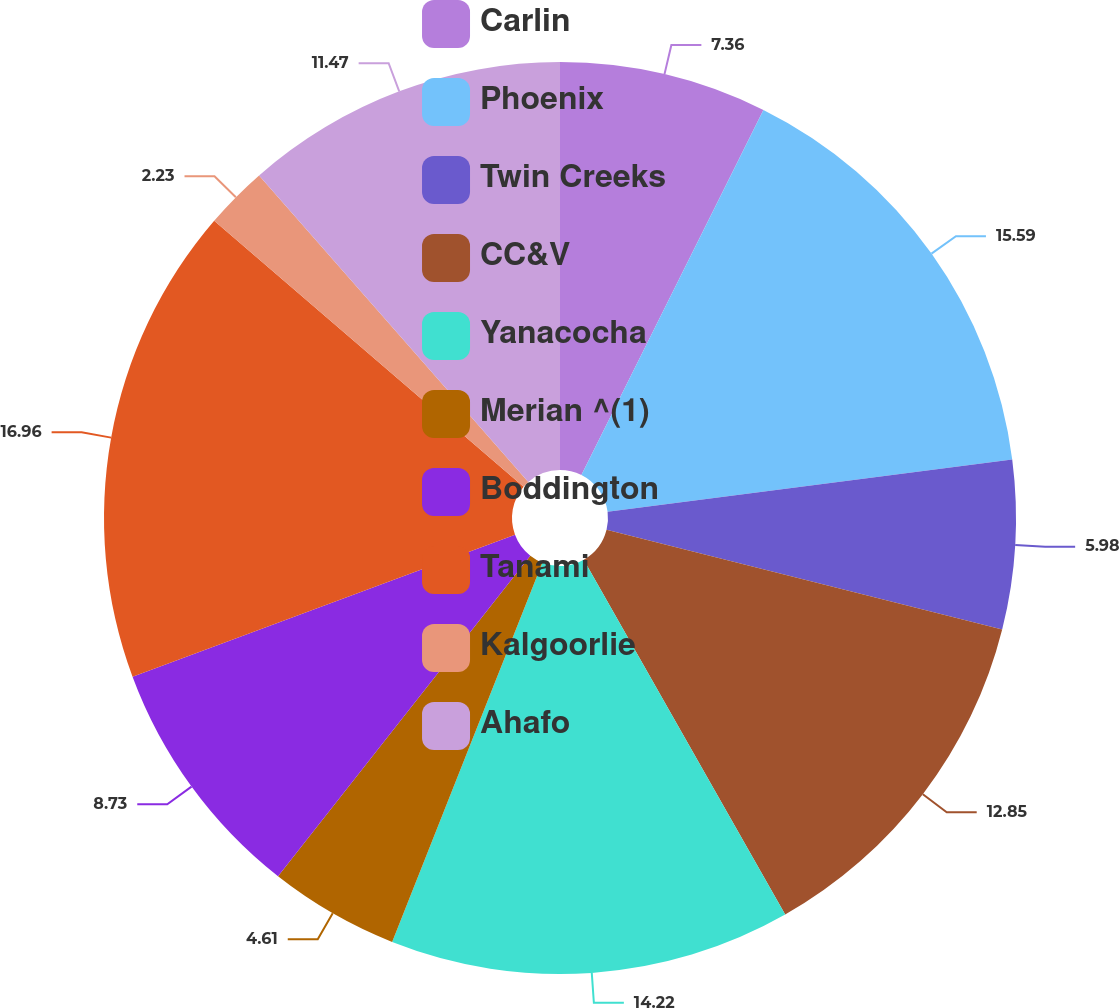Convert chart. <chart><loc_0><loc_0><loc_500><loc_500><pie_chart><fcel>Carlin<fcel>Phoenix<fcel>Twin Creeks<fcel>CC&V<fcel>Yanacocha<fcel>Merian ^(1)<fcel>Boddington<fcel>Tanami<fcel>Kalgoorlie<fcel>Ahafo<nl><fcel>7.36%<fcel>15.59%<fcel>5.98%<fcel>12.85%<fcel>14.22%<fcel>4.61%<fcel>8.73%<fcel>16.96%<fcel>2.23%<fcel>11.47%<nl></chart> 